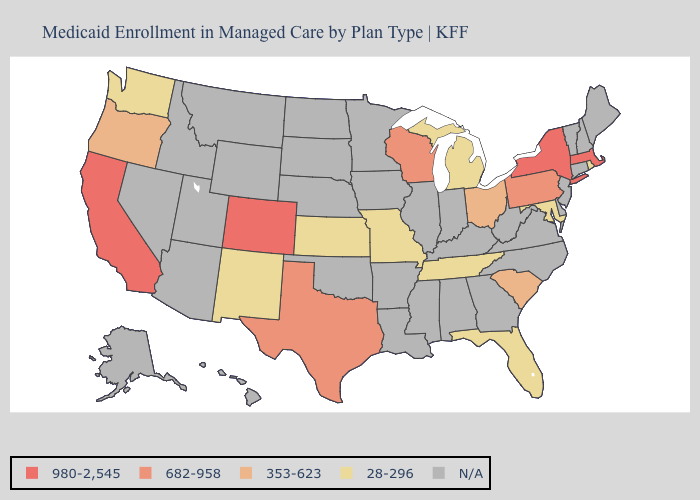What is the value of Arkansas?
Quick response, please. N/A. What is the value of Wyoming?
Concise answer only. N/A. Name the states that have a value in the range 682-958?
Be succinct. Pennsylvania, Texas, Wisconsin. What is the highest value in states that border Kentucky?
Be succinct. 353-623. Name the states that have a value in the range 682-958?
Write a very short answer. Pennsylvania, Texas, Wisconsin. What is the value of North Carolina?
Give a very brief answer. N/A. What is the value of Florida?
Keep it brief. 28-296. Which states have the lowest value in the South?
Keep it brief. Florida, Maryland, Tennessee. Name the states that have a value in the range 682-958?
Short answer required. Pennsylvania, Texas, Wisconsin. What is the value of Hawaii?
Concise answer only. N/A. What is the value of California?
Give a very brief answer. 980-2,545. Name the states that have a value in the range N/A?
Concise answer only. Alabama, Alaska, Arizona, Arkansas, Connecticut, Delaware, Georgia, Hawaii, Idaho, Illinois, Indiana, Iowa, Kentucky, Louisiana, Maine, Minnesota, Mississippi, Montana, Nebraska, Nevada, New Hampshire, New Jersey, North Carolina, North Dakota, Oklahoma, South Dakota, Utah, Vermont, Virginia, West Virginia, Wyoming. What is the value of California?
Answer briefly. 980-2,545. 